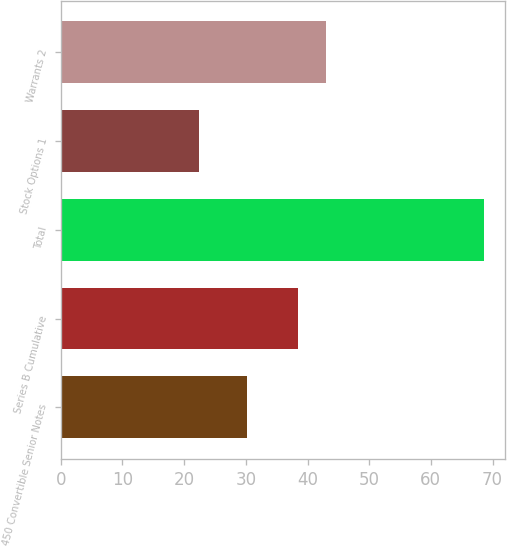Convert chart to OTSL. <chart><loc_0><loc_0><loc_500><loc_500><bar_chart><fcel>450 Convertible Senior Notes<fcel>Series B Cumulative<fcel>Total<fcel>Stock Options 1<fcel>Warrants 2<nl><fcel>30.2<fcel>38.4<fcel>68.6<fcel>22.4<fcel>43.02<nl></chart> 